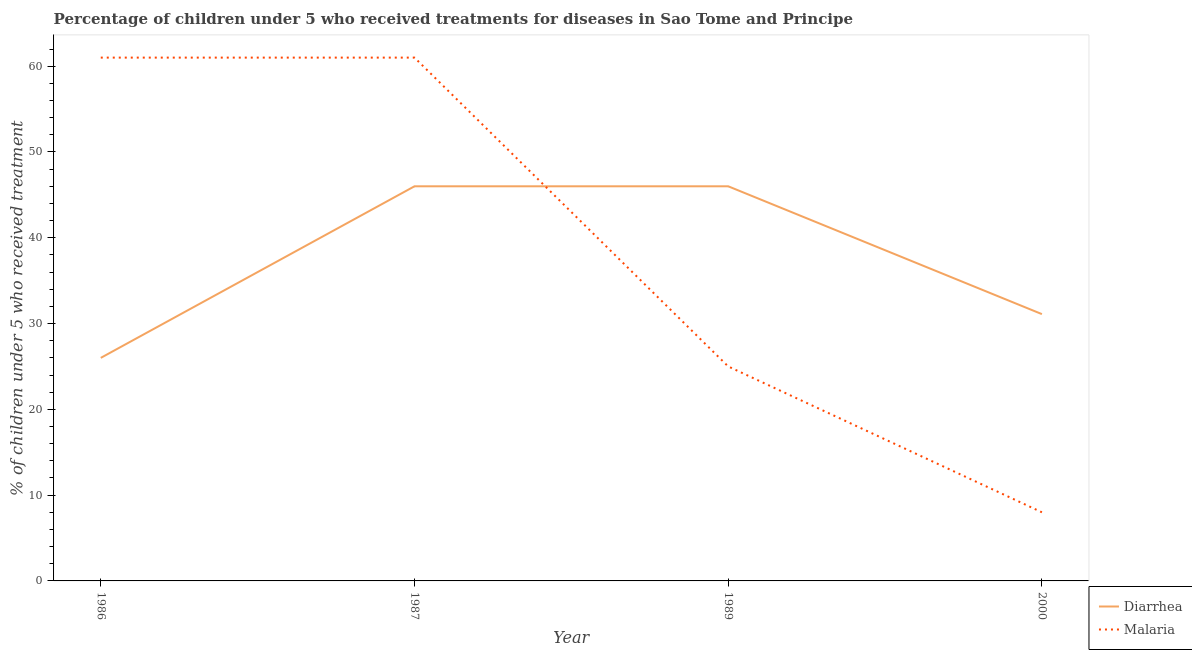Does the line corresponding to percentage of children who received treatment for diarrhoea intersect with the line corresponding to percentage of children who received treatment for malaria?
Ensure brevity in your answer.  Yes. Across all years, what is the minimum percentage of children who received treatment for malaria?
Your response must be concise. 8. In which year was the percentage of children who received treatment for malaria maximum?
Keep it short and to the point. 1986. In which year was the percentage of children who received treatment for diarrhoea minimum?
Keep it short and to the point. 1986. What is the total percentage of children who received treatment for malaria in the graph?
Provide a short and direct response. 155. What is the difference between the percentage of children who received treatment for diarrhoea in 1987 and that in 2000?
Offer a very short reply. 14.9. What is the difference between the percentage of children who received treatment for malaria in 1989 and the percentage of children who received treatment for diarrhoea in 2000?
Provide a short and direct response. -6.1. What is the average percentage of children who received treatment for diarrhoea per year?
Keep it short and to the point. 37.27. What is the ratio of the percentage of children who received treatment for malaria in 1986 to that in 1987?
Keep it short and to the point. 1. Is the difference between the percentage of children who received treatment for diarrhoea in 1989 and 2000 greater than the difference between the percentage of children who received treatment for malaria in 1989 and 2000?
Ensure brevity in your answer.  No. What is the difference between the highest and the second highest percentage of children who received treatment for malaria?
Provide a succinct answer. 0. What is the difference between the highest and the lowest percentage of children who received treatment for malaria?
Your answer should be very brief. 53. In how many years, is the percentage of children who received treatment for malaria greater than the average percentage of children who received treatment for malaria taken over all years?
Offer a terse response. 2. Does the percentage of children who received treatment for malaria monotonically increase over the years?
Provide a short and direct response. No. How many years are there in the graph?
Your answer should be very brief. 4. Are the values on the major ticks of Y-axis written in scientific E-notation?
Make the answer very short. No. Does the graph contain any zero values?
Offer a terse response. No. How many legend labels are there?
Provide a succinct answer. 2. What is the title of the graph?
Keep it short and to the point. Percentage of children under 5 who received treatments for diseases in Sao Tome and Principe. What is the label or title of the Y-axis?
Give a very brief answer. % of children under 5 who received treatment. What is the % of children under 5 who received treatment of Diarrhea in 1986?
Keep it short and to the point. 26. What is the % of children under 5 who received treatment of Malaria in 1986?
Your response must be concise. 61. What is the % of children under 5 who received treatment in Diarrhea in 1987?
Ensure brevity in your answer.  46. What is the % of children under 5 who received treatment of Malaria in 1987?
Your answer should be very brief. 61. What is the % of children under 5 who received treatment in Malaria in 1989?
Offer a very short reply. 25. What is the % of children under 5 who received treatment of Diarrhea in 2000?
Your response must be concise. 31.1. Across all years, what is the maximum % of children under 5 who received treatment of Malaria?
Offer a very short reply. 61. Across all years, what is the minimum % of children under 5 who received treatment of Malaria?
Give a very brief answer. 8. What is the total % of children under 5 who received treatment in Diarrhea in the graph?
Give a very brief answer. 149.1. What is the total % of children under 5 who received treatment in Malaria in the graph?
Your answer should be compact. 155. What is the difference between the % of children under 5 who received treatment in Diarrhea in 1986 and that in 1987?
Your answer should be very brief. -20. What is the difference between the % of children under 5 who received treatment in Malaria in 1986 and that in 1987?
Give a very brief answer. 0. What is the difference between the % of children under 5 who received treatment of Malaria in 1986 and that in 1989?
Keep it short and to the point. 36. What is the difference between the % of children under 5 who received treatment in Malaria in 1986 and that in 2000?
Your answer should be compact. 53. What is the difference between the % of children under 5 who received treatment in Malaria in 1987 and that in 1989?
Keep it short and to the point. 36. What is the difference between the % of children under 5 who received treatment of Malaria in 1987 and that in 2000?
Your response must be concise. 53. What is the difference between the % of children under 5 who received treatment in Diarrhea in 1989 and that in 2000?
Your response must be concise. 14.9. What is the difference between the % of children under 5 who received treatment of Diarrhea in 1986 and the % of children under 5 who received treatment of Malaria in 1987?
Offer a terse response. -35. What is the difference between the % of children under 5 who received treatment in Diarrhea in 1986 and the % of children under 5 who received treatment in Malaria in 2000?
Your answer should be compact. 18. What is the average % of children under 5 who received treatment of Diarrhea per year?
Offer a very short reply. 37.27. What is the average % of children under 5 who received treatment of Malaria per year?
Give a very brief answer. 38.75. In the year 1986, what is the difference between the % of children under 5 who received treatment in Diarrhea and % of children under 5 who received treatment in Malaria?
Offer a very short reply. -35. In the year 1987, what is the difference between the % of children under 5 who received treatment in Diarrhea and % of children under 5 who received treatment in Malaria?
Your answer should be compact. -15. In the year 2000, what is the difference between the % of children under 5 who received treatment of Diarrhea and % of children under 5 who received treatment of Malaria?
Offer a very short reply. 23.1. What is the ratio of the % of children under 5 who received treatment in Diarrhea in 1986 to that in 1987?
Provide a succinct answer. 0.57. What is the ratio of the % of children under 5 who received treatment in Diarrhea in 1986 to that in 1989?
Provide a short and direct response. 0.57. What is the ratio of the % of children under 5 who received treatment of Malaria in 1986 to that in 1989?
Ensure brevity in your answer.  2.44. What is the ratio of the % of children under 5 who received treatment in Diarrhea in 1986 to that in 2000?
Keep it short and to the point. 0.84. What is the ratio of the % of children under 5 who received treatment in Malaria in 1986 to that in 2000?
Offer a very short reply. 7.62. What is the ratio of the % of children under 5 who received treatment of Diarrhea in 1987 to that in 1989?
Offer a terse response. 1. What is the ratio of the % of children under 5 who received treatment of Malaria in 1987 to that in 1989?
Your answer should be compact. 2.44. What is the ratio of the % of children under 5 who received treatment in Diarrhea in 1987 to that in 2000?
Your answer should be compact. 1.48. What is the ratio of the % of children under 5 who received treatment of Malaria in 1987 to that in 2000?
Offer a very short reply. 7.62. What is the ratio of the % of children under 5 who received treatment in Diarrhea in 1989 to that in 2000?
Your answer should be compact. 1.48. What is the ratio of the % of children under 5 who received treatment in Malaria in 1989 to that in 2000?
Offer a very short reply. 3.12. What is the difference between the highest and the second highest % of children under 5 who received treatment in Diarrhea?
Ensure brevity in your answer.  0. What is the difference between the highest and the second highest % of children under 5 who received treatment in Malaria?
Provide a succinct answer. 0. What is the difference between the highest and the lowest % of children under 5 who received treatment in Malaria?
Offer a very short reply. 53. 